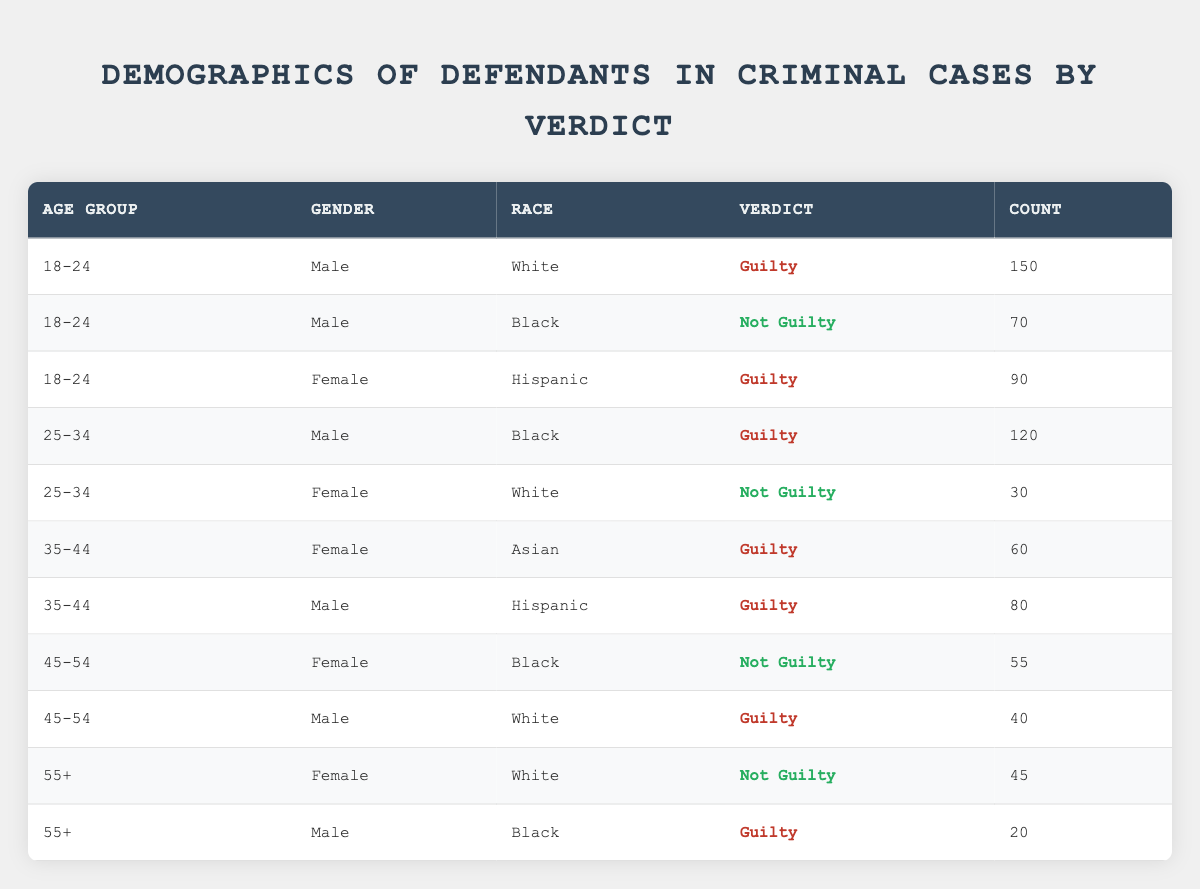What is the count of Male defendants aged 18-24 who were found Guilty? Referring to the table, in the row where the age group is "18-24", the gender is "Male", and the verdict is "Guilty", the count is given as 150.
Answer: 150 How many defendants aged 25-34 received a Not Guilty verdict? Looking at the table, there is one row for the age group "25-34", gender "Female", race "White", and verdict "Not Guilty", which has a count of 30. There are no other rows under this age group with a Not Guilty verdict.
Answer: 30 What is the total count of Guilty verdicts for all Female defendants? To find this, I need to sum the counts across all rows in which the gender is "Female" and the verdict is "Guilty". From the data, the counts are 90 (Hispanic) + 60 (Asian) = 150.
Answer: 150 Is there a defendant aged 55+ who was found Not Guilty? In the table, there are rows for age group "55+", but only Female defendants with a race of "White" are found with a Not Guilty verdict in that age group. Therefore, the answer is yes.
Answer: Yes What is the difference in count between Guilty verdicts for Black Male defendants aged 25-34 and 55+? The count for Black Male defendants aged 25-34 with a Guilty verdict is 120, while for those aged 55+, it is 20. The difference is calculated as 120 - 20 = 100.
Answer: 100 How many defendants in total were found Not Guilty across all age groups? I will look at all rows with a verdict of "Not Guilty": 70 (Black Male, age 18-24) + 30 (White Female, age 25-34) + 55 (Black Female, age 45-54) + 45 (White Female, age 55+) = 200.
Answer: 200 What is the total count of defendants aged 35-44 who were found Guilty? In the age group "35-44", there are two defendants: 60 (Asian Female) and 80 (Hispanic Male). Adding these gives a total of 140 defendants aged 35-44 found Guilty.
Answer: 140 Do any Female defendants aged 45-54 have a Guilty verdict? In the table, under the age group "45-54", the only Female defendant listed has a Not Guilty verdict (Black Female). Therefore, there are no Female defendants aged 45-54 with a Guilty verdict.
Answer: No 